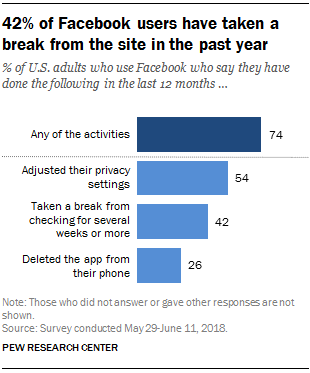Outline some significant characteristics in this image. The ratio between choosing to delete the app and adjusting privacy settings is approximately 1.120833333... Out of all users, 26% have chosen to delete the app. 